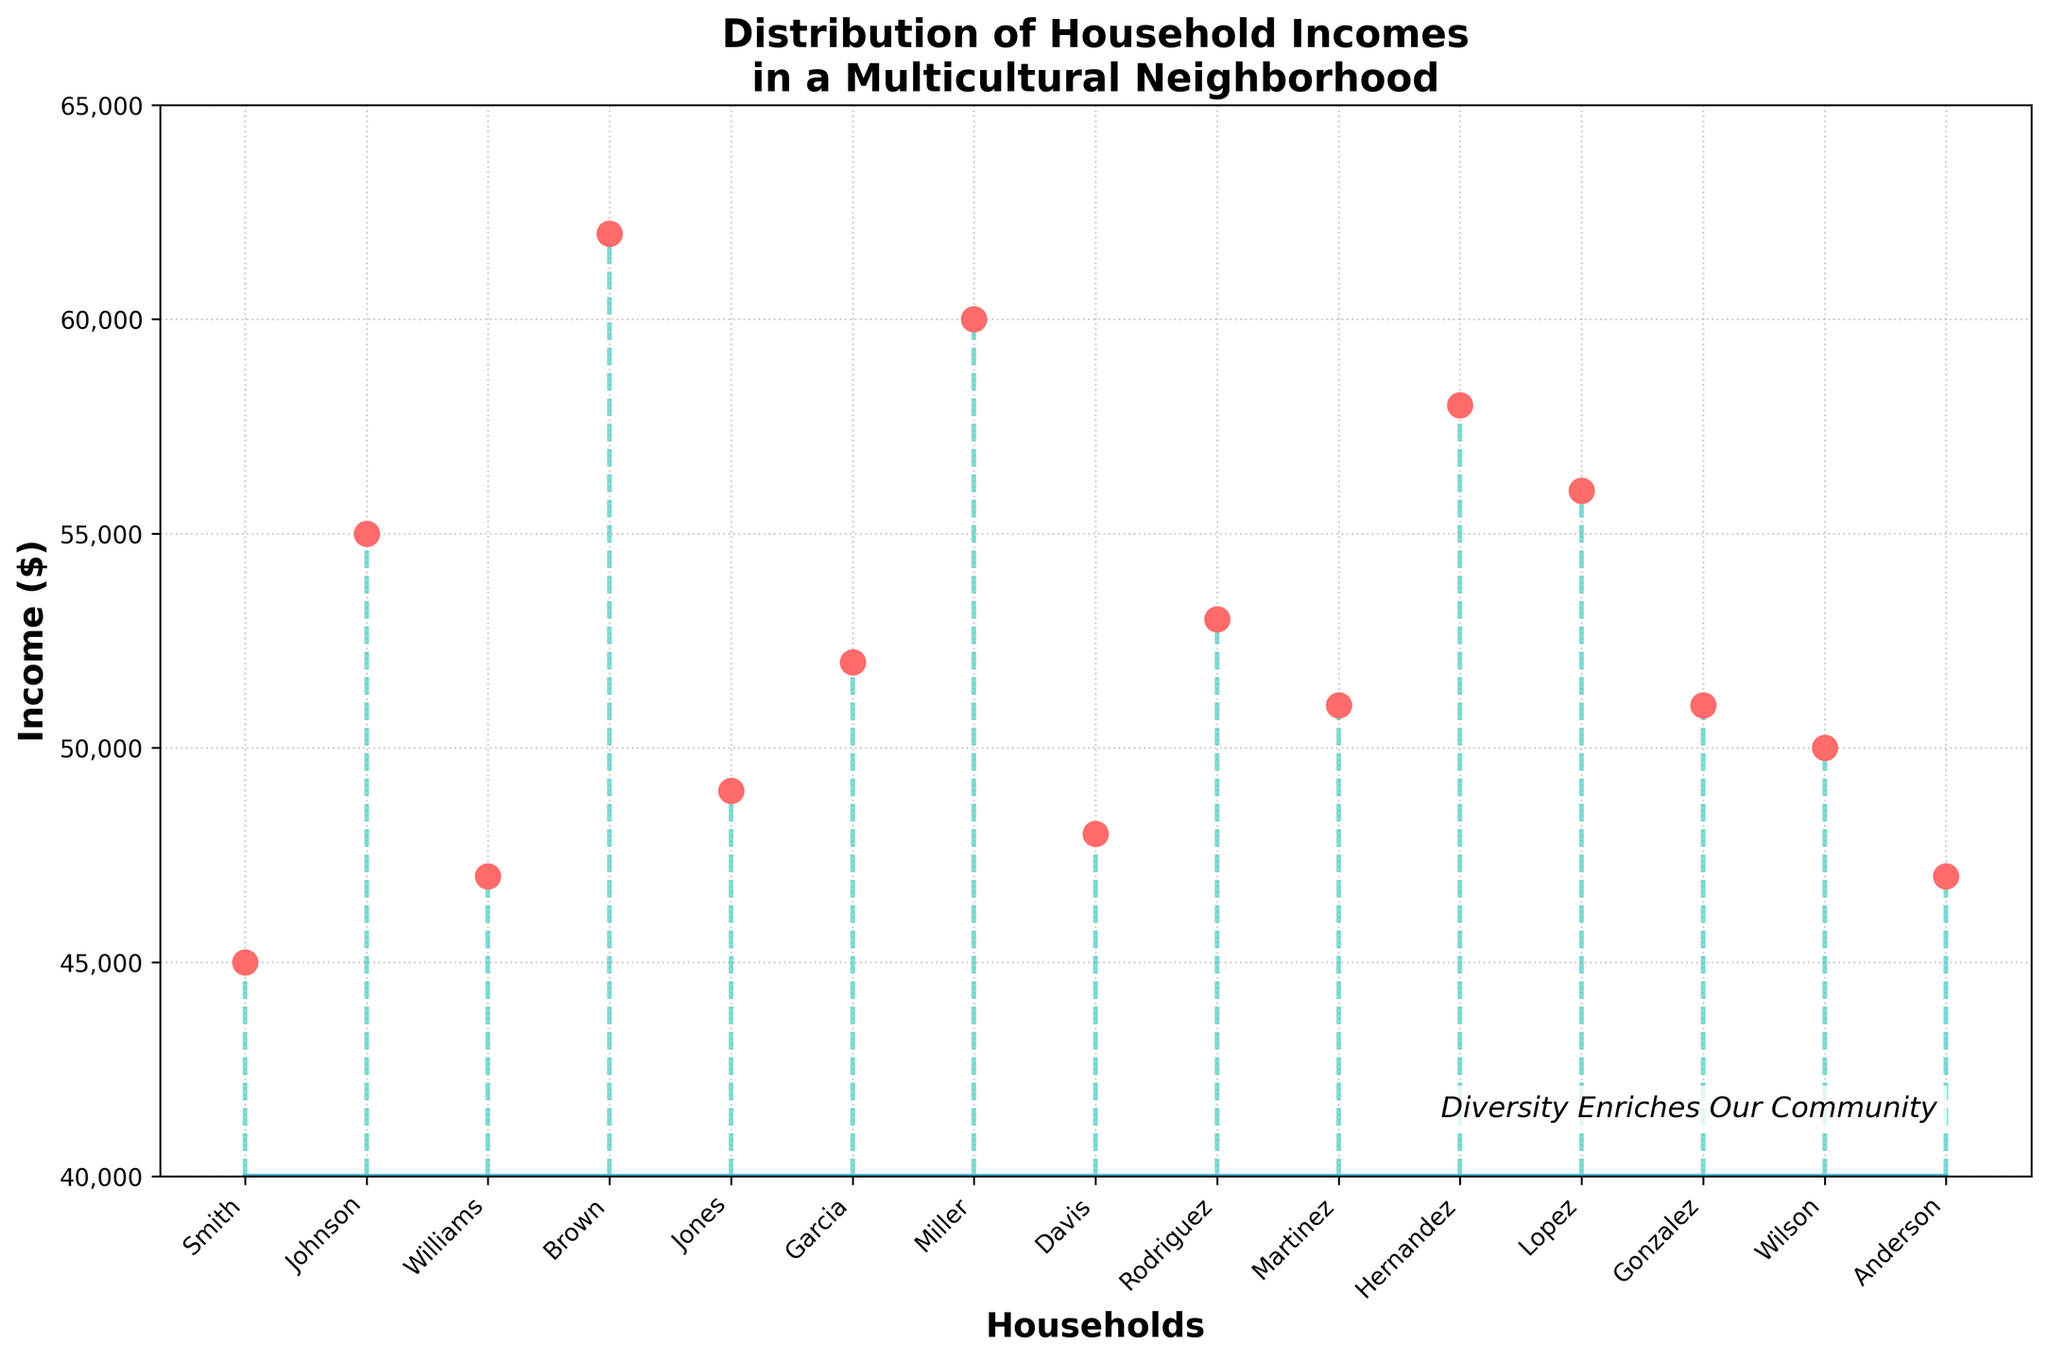What is the title of the plot? The title of the plot is displayed at the top of the figure. It reads "Distribution of Household Incomes in a Multicultural Neighborhood".
Answer: Distribution of Household Incomes in a Multicultural Neighborhood How many households are represented in the plot? By counting the number of markers (circles) on the stem plot, we can see there are 15 households represented.
Answer: 15 What is the highest household income shown in the plot? By observing the vertical positions of the markers, the highest marker corresponds to the income of $62,000.
Answer: $62,000 Which household has the lowest income? The household names are listed along the x-axis, and the lowest marker falls in line with "Smith", which has an income of $45,000.
Answer: Smith What is the median household income in this neighborhood? To find the median, we list all incomes in ascending order and find the middle value. Ordered incomes: 45000, 47000, 47000, 48000, 49000, 50000, 51000, 51000, 52000, 53000, 55000, 56000, 58000, 60000, 62000. The middle value is the 8th one, which is $51,000.
Answer: $51,000 Which households have an income equal to $51,000? Checking along the vertical axis for $51,000 and matching the horizontal labels, both "Martinez" and "Gonzalez" align with this value.
Answer: Martinez, Gonzalez What is the average (mean) household income? Add up all incomes and divide by the number of households: (45000 + 55000 + 47000 + 62000 + 49000 + 52000 + 60000 + 48000 + 53000 + 51000 + 58000 + 56000 + 51000 + 50000 + 47000) / 15 = 51,933.33.
Answer: $51,933.33 Compare the incomes of "Johnson" and "Lopez". Which one is greater and by how much? Johnson's income is $55,000 and Lopez's income is $56,000. Lopez's income is greater by $56,000 - $55,000 = $1,000.
Answer: Lopez, $1,000 Is there a noticeable trend or pattern in household incomes in this neighborhood? Observing the stem plot, the incomes are generally spread out without a steep increase or decrease, but many incomes cluster between $45,000 and $60,000, indicating no extreme variation.
Answer: Cluster between $45,000 and $60,000 How does the income of "Brown" compare to the median household income? Brown's income is $62,000, and the median is $51,000. Brown's income is higher than the median by $62,000 - $51,000 = $11,000.
Answer: $11,000 more 